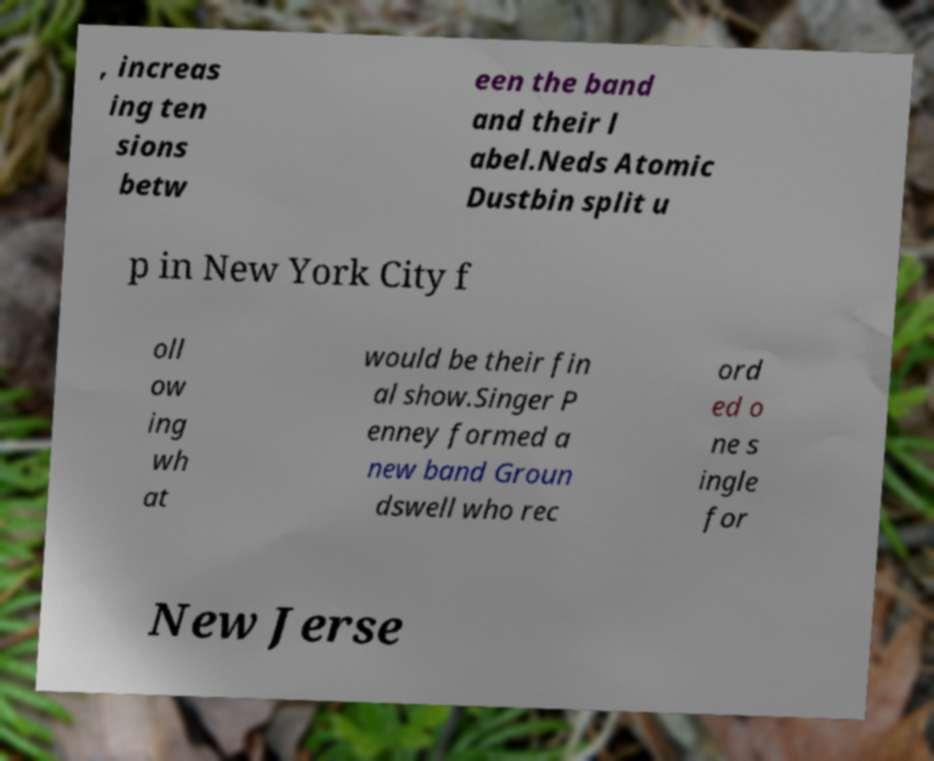For documentation purposes, I need the text within this image transcribed. Could you provide that? , increas ing ten sions betw een the band and their l abel.Neds Atomic Dustbin split u p in New York City f oll ow ing wh at would be their fin al show.Singer P enney formed a new band Groun dswell who rec ord ed o ne s ingle for New Jerse 